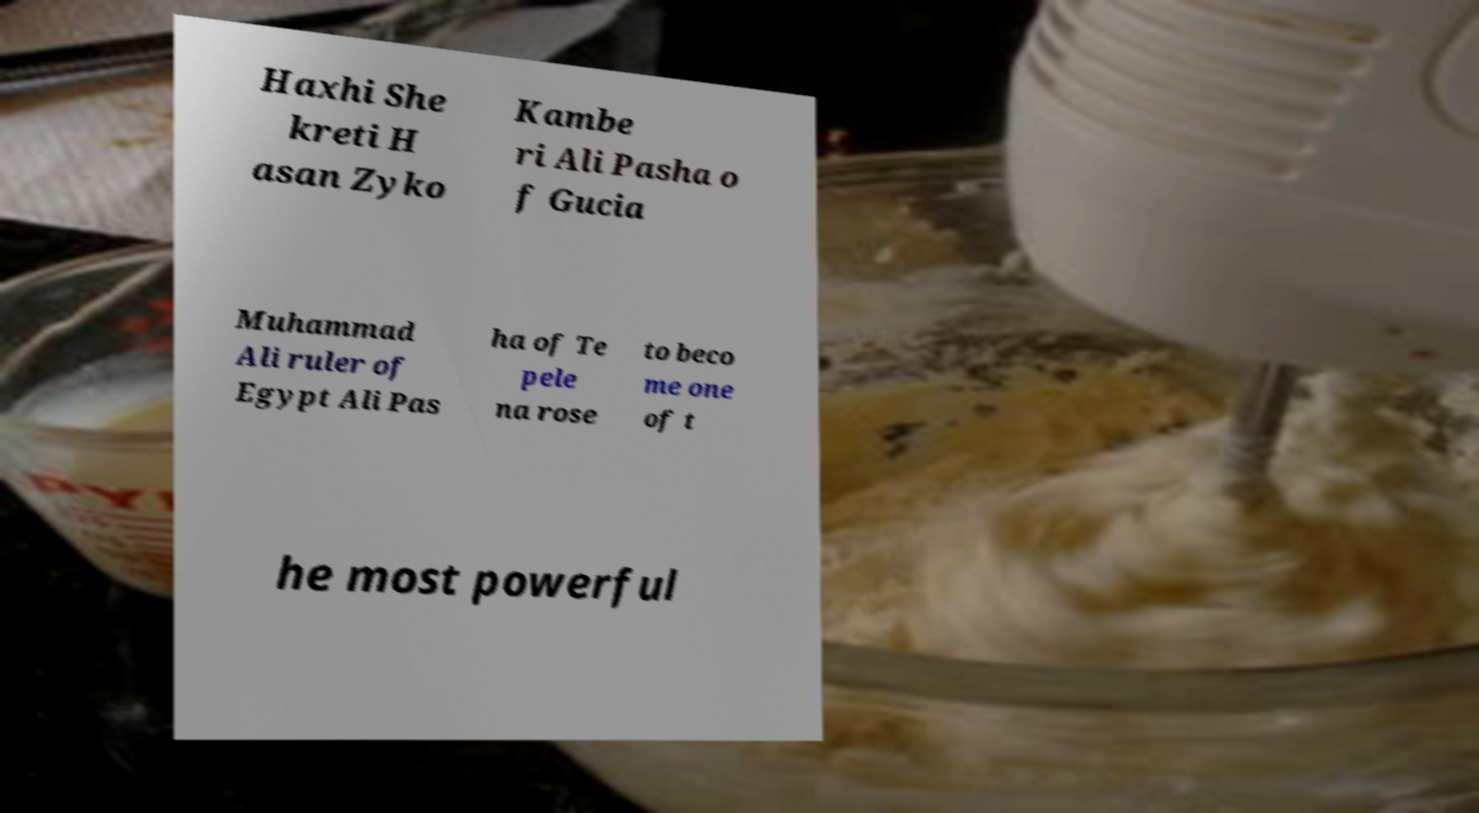I need the written content from this picture converted into text. Can you do that? Haxhi She kreti H asan Zyko Kambe ri Ali Pasha o f Gucia Muhammad Ali ruler of Egypt Ali Pas ha of Te pele na rose to beco me one of t he most powerful 